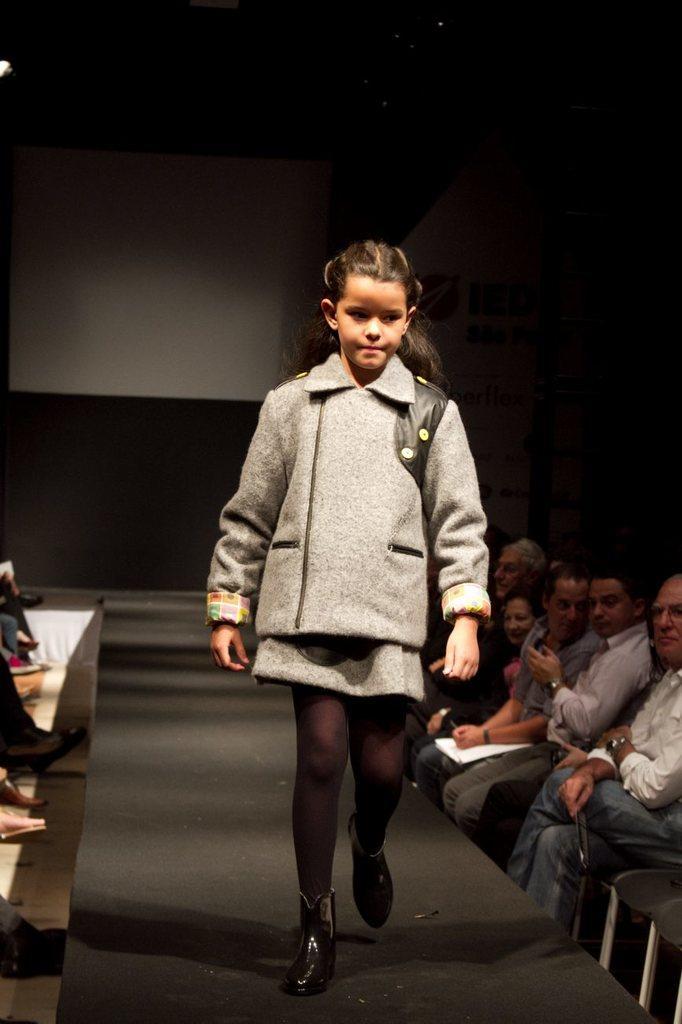In one or two sentences, can you explain what this image depicts? In this image we can see a girl is walking on ramp. Both sides of the image people are sitting on chairs. 